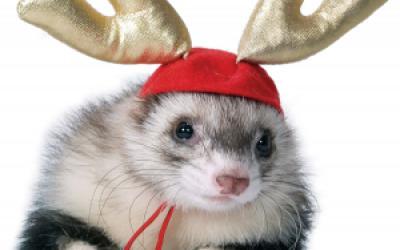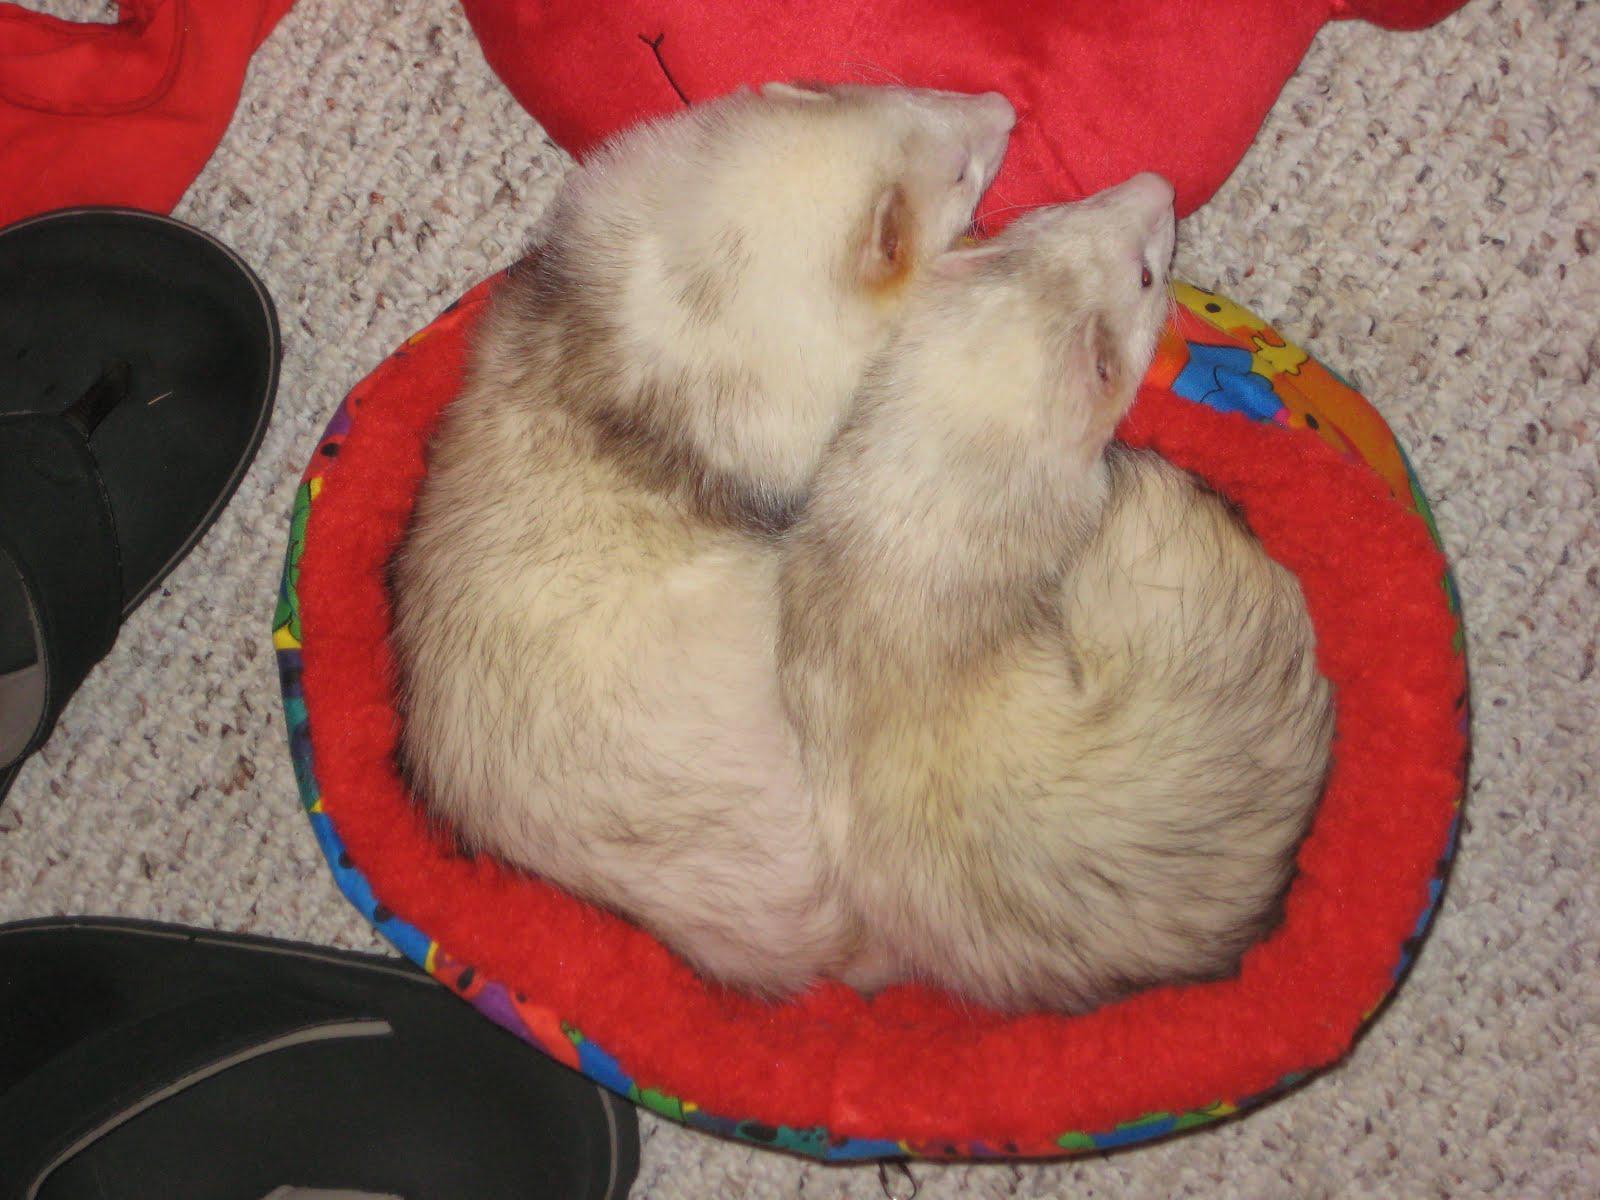The first image is the image on the left, the second image is the image on the right. Examine the images to the left and right. Is the description "The single ferret on the left hand side is dressed up with an accessory while the right hand image shows exactly two ferrets." accurate? Answer yes or no. Yes. The first image is the image on the left, the second image is the image on the right. Assess this claim about the two images: "The animal in the image on the left is wearing an article of clothing.". Correct or not? Answer yes or no. Yes. 